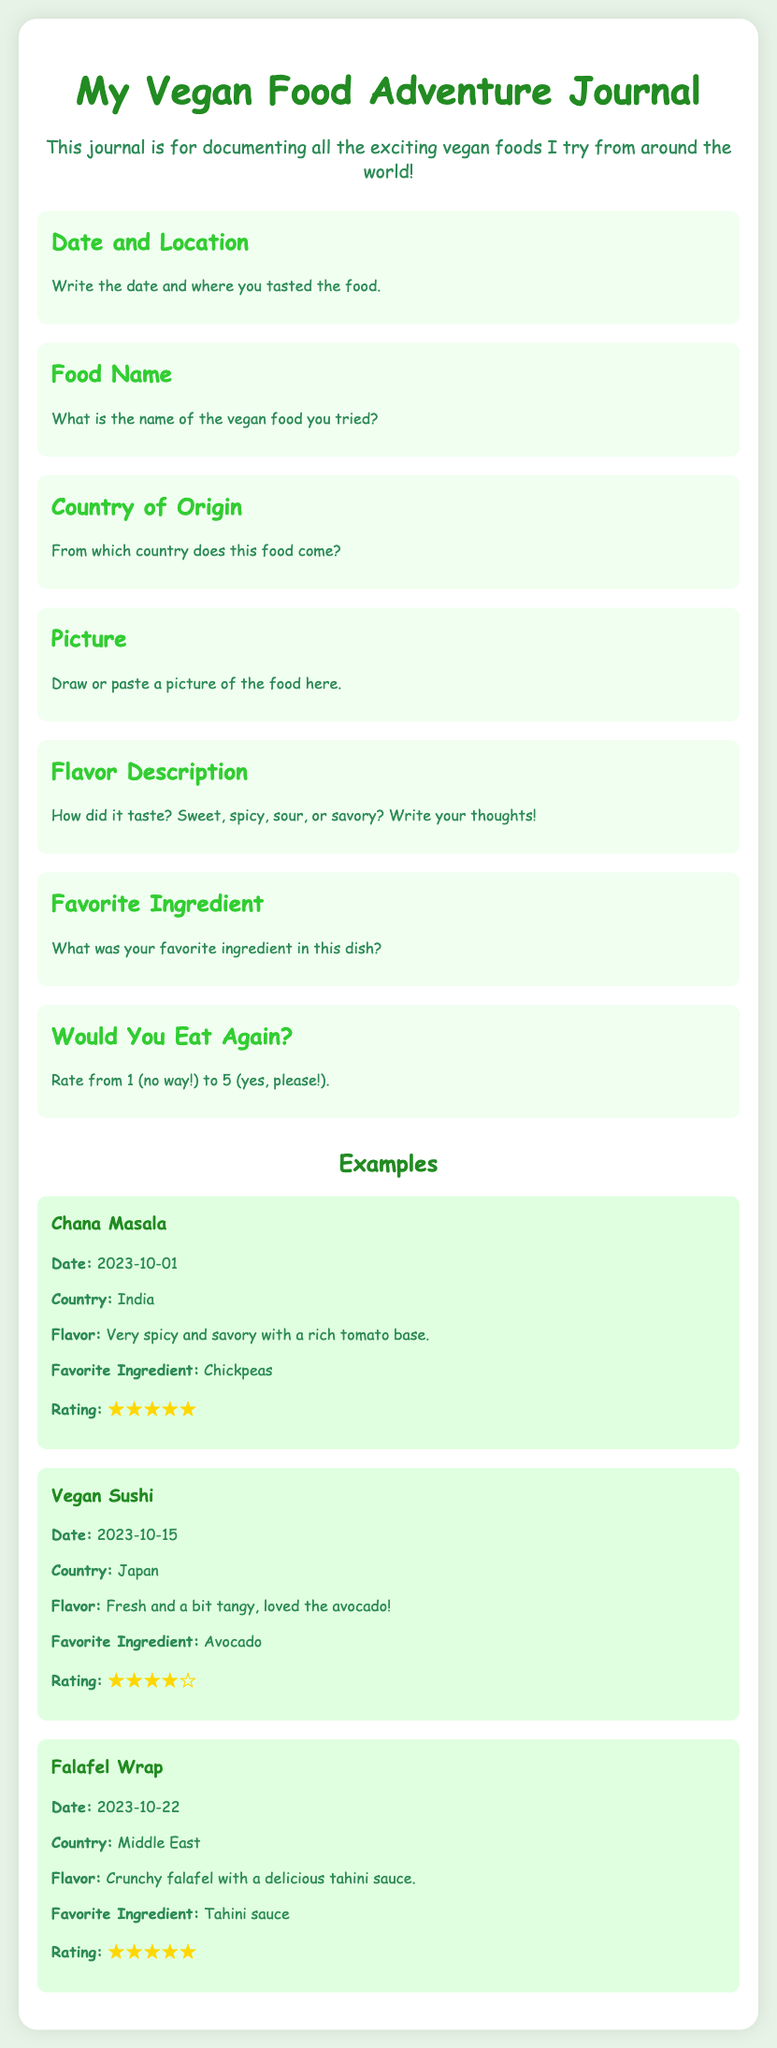what is the title of the journal? The title of the journal is displayed at the top of the document.
Answer: My Vegan Food Adventure Journal what is the first section of the journal about? The first section asks for the date and location where the food was tasted.
Answer: Date and Location which country does Chana Masala come from? The country of origin for Chana Masala is stated in its example section.
Answer: India how would you describe the flavor of Vegan Sushi? The flavor description of Vegan Sushi is provided in the example section.
Answer: Fresh and a bit tangy what was the favorite ingredient in the Falafel Wrap? The favorite ingredient for the Falafel Wrap example is mentioned.
Answer: Tahini sauce how many examples of food are provided in the journal? The number of examples can be counted in the "Examples" section.
Answer: Three what is the purpose of this journal? The purpose is outlined in the introductory paragraph of the document.
Answer: Documenting all the exciting vegan foods what is the highest rating given in the examples? The ratings are indicated in the examples, and the highest can be identified.
Answer: 5 